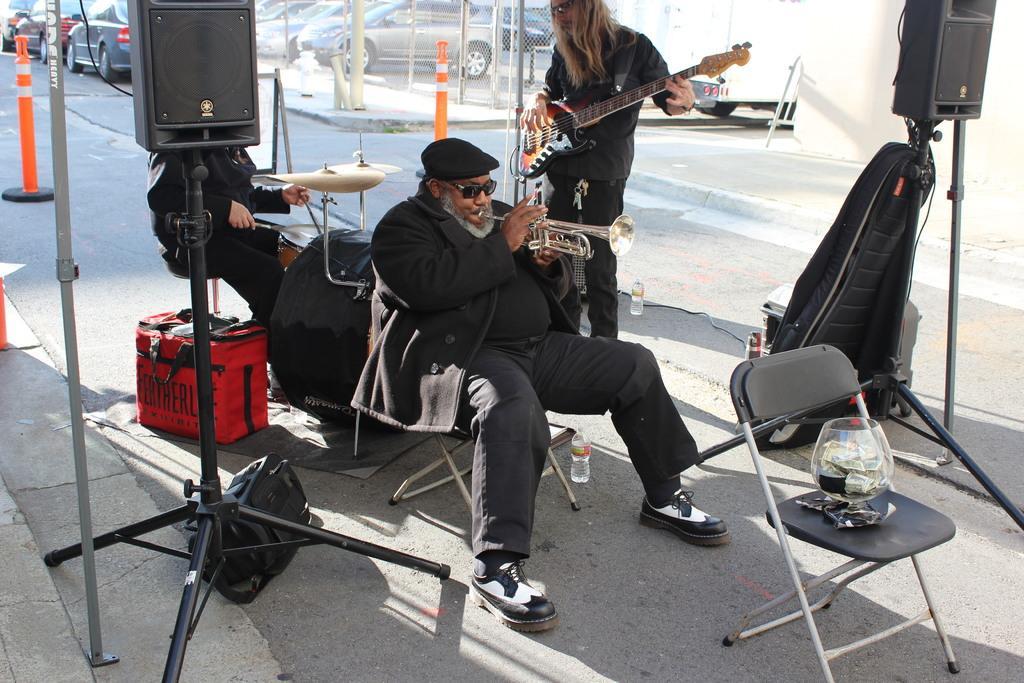Can you describe this image briefly? In this image in the center there is one person who is sitting on a chair, and he is holding a musical instrument and playing. In the background there is another person who is holding a guitar and playing, and on the left side there is one person who is sitting on a chair and he is playing drums. And there are some speakers, bags, chairs, bottle on the floor, and in the background there are some cars, poles and net. 